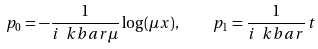Convert formula to latex. <formula><loc_0><loc_0><loc_500><loc_500>p _ { 0 } = - \frac { 1 } { i \ k b a r \mu } \log ( \mu x ) , \quad p _ { 1 } = \frac { 1 } { i \ k b a r } \, t</formula> 